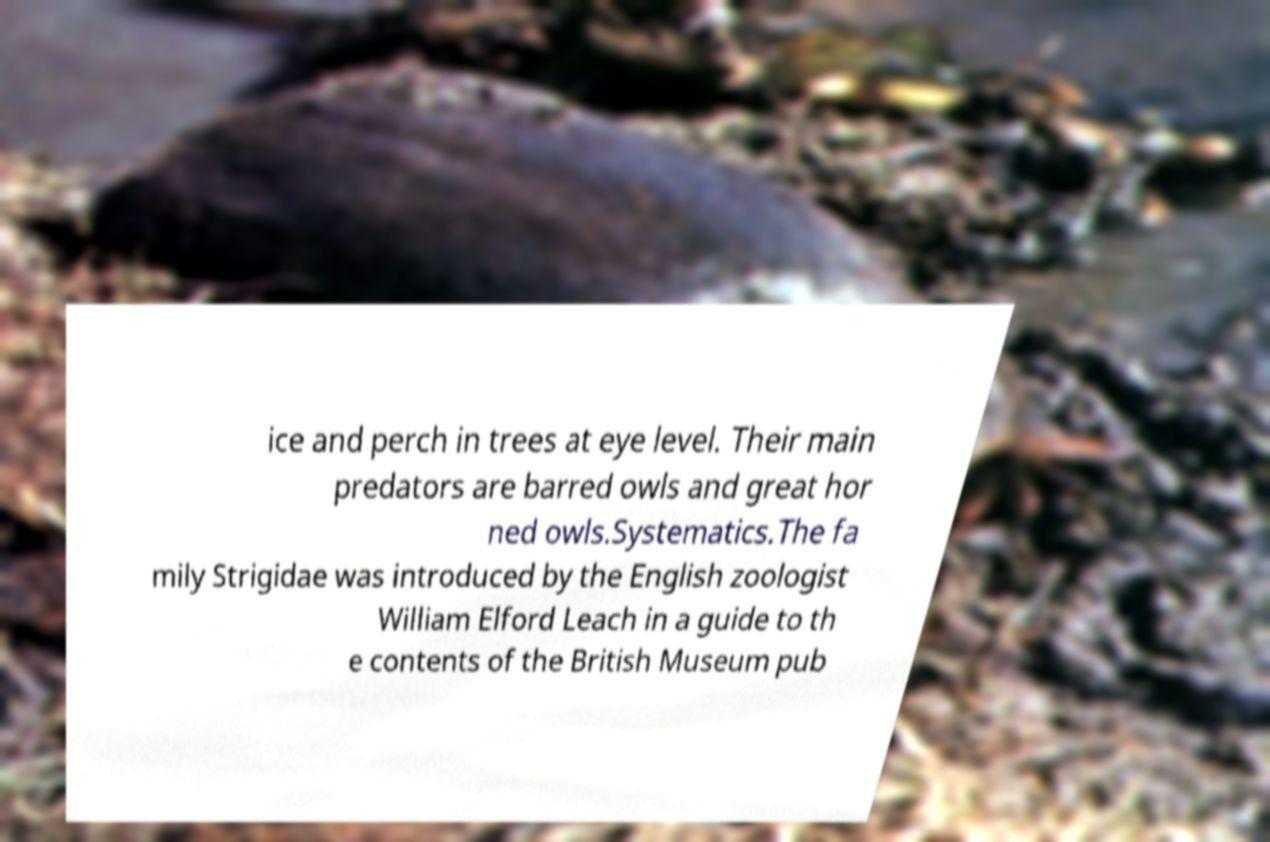Please identify and transcribe the text found in this image. ice and perch in trees at eye level. Their main predators are barred owls and great hor ned owls.Systematics.The fa mily Strigidae was introduced by the English zoologist William Elford Leach in a guide to th e contents of the British Museum pub 